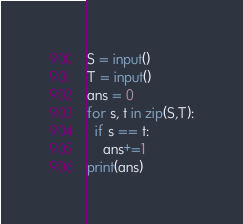<code> <loc_0><loc_0><loc_500><loc_500><_Python_>S = input()
T = input()
ans = 0
for s, t in zip(S,T):
  if s == t:
    ans+=1
print(ans)</code> 